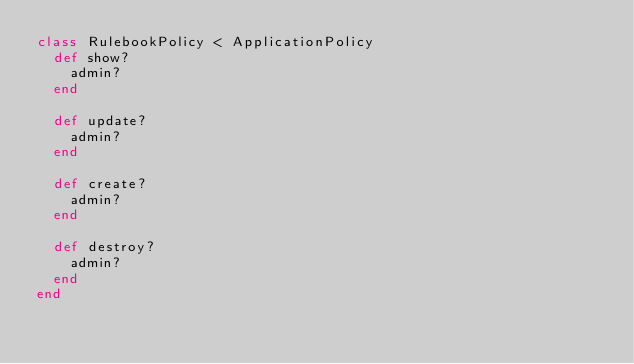Convert code to text. <code><loc_0><loc_0><loc_500><loc_500><_Ruby_>class RulebookPolicy < ApplicationPolicy
  def show?
    admin?
  end

  def update?
    admin?
  end

  def create?
    admin?
  end

  def destroy?
    admin?
  end
end
</code> 